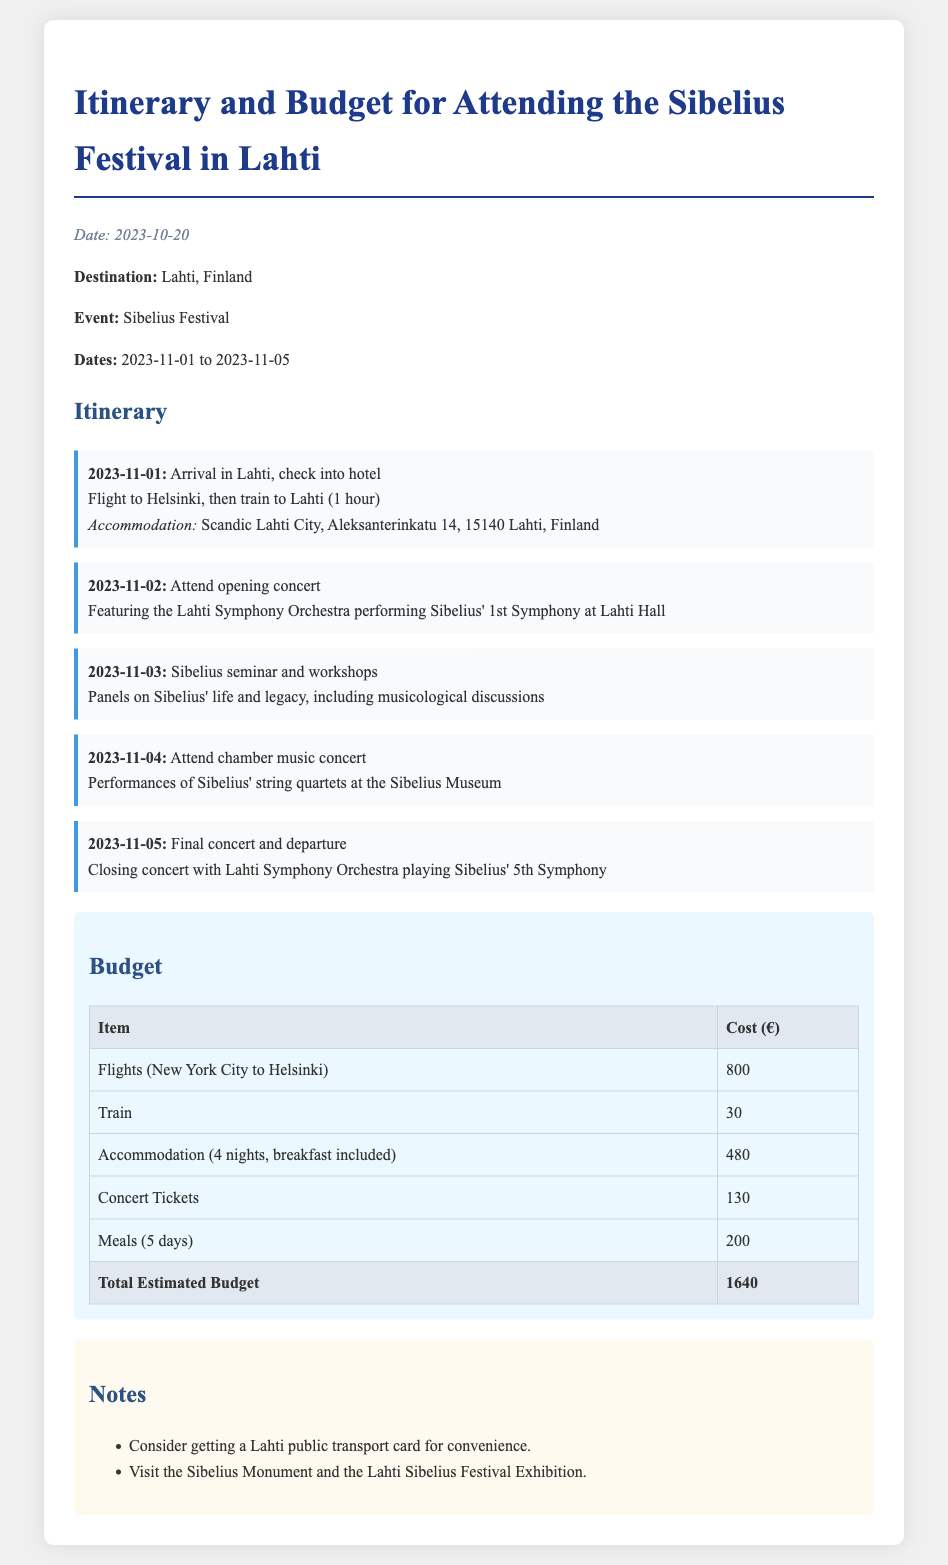What are the dates of the Sibelius Festival? The document states that the Sibelius Festival takes place from 2023-11-01 to 2023-11-05.
Answer: 2023-11-01 to 2023-11-05 What is the total estimated budget for the trip? The total estimated budget is provided in the budget section of the document, which sums up all the costs.
Answer: 1640 Where is the accommodation located? The document mentions that the accommodation is at Scandic Lahti City, Aleksanterinkatu 14, 15140 Lahti, Finland.
Answer: Scandic Lahti City, Aleksanterinkatu 14, 15140 Lahti, Finland What concert is scheduled for 2023-11-02? The schedule for 2023-11-02 indicates attendance at the opening concert featuring the Lahti Symphony Orchestra performing Sibelius' 1st Symphony.
Answer: Lahti Symphony Orchestra performing Sibelius' 1st Symphony What item has the highest cost in the budget? Upon reviewing the budget table, the item with the highest cost is the flights from New York City to Helsinki.
Answer: Flights (New York City to Helsinki) How many nights will the accommodation be booked? The document reveals that the accommodation is for 4 nights, including breakfast.
Answer: 4 nights What additional item is suggested in the notes section? The notes section includes recommendations, specifically mentioning getting a Lahti public transport card for convenience.
Answer: Lahti public transport card Which orchestra plays the final concert? According to the final concert details, it will be performed by the Lahti Symphony Orchestra playing Sibelius' 5th Symphony.
Answer: Lahti Symphony Orchestra 